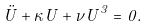Convert formula to latex. <formula><loc_0><loc_0><loc_500><loc_500>\ddot { U } + \kappa U + \nu U ^ { 3 } = 0 .</formula> 